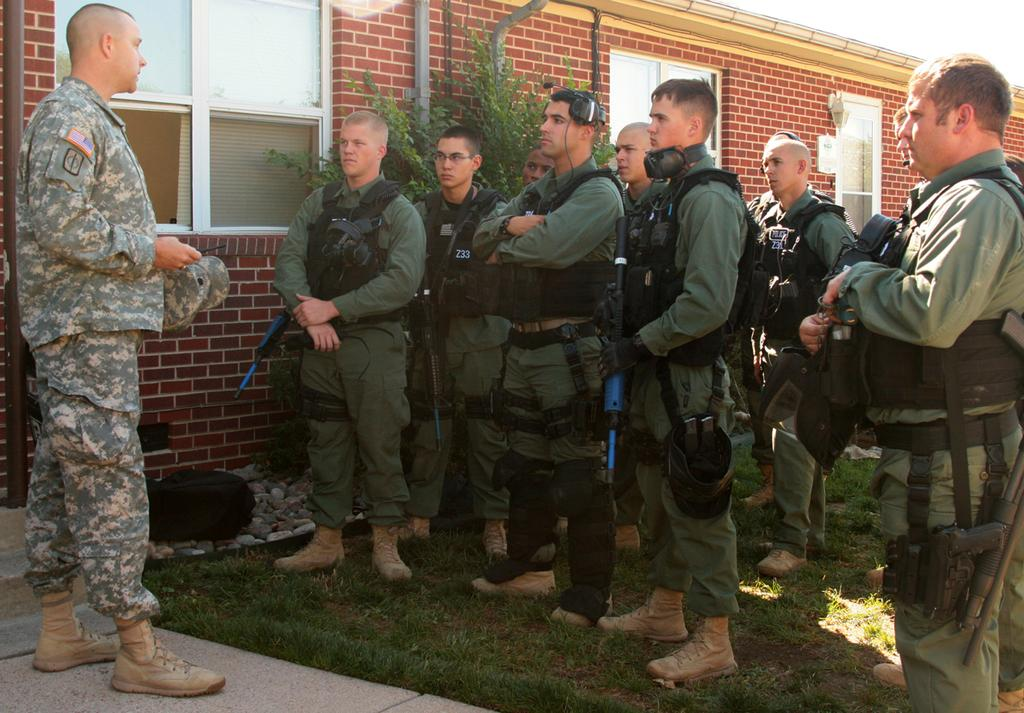What is the primary subject of the image? There are men standing in the image. Can you describe the surface on which the men are standing? The men are standing on the floor and ground. What can be seen in the background of the image? There are trees, buildings, stones, and the sky visible in the background of the image. What type of leaf is being used as waste in the image? There is no leaf being used as waste in the image. 